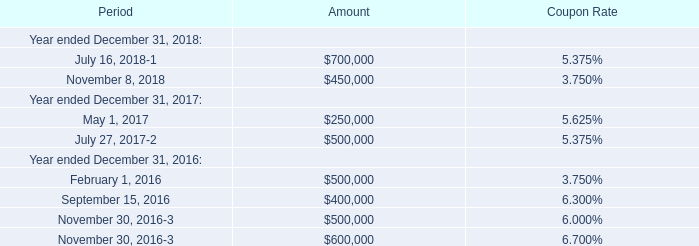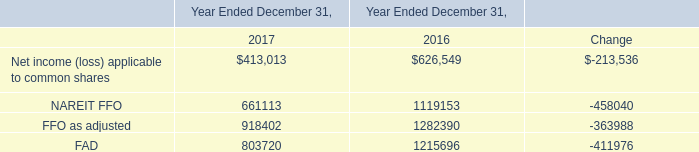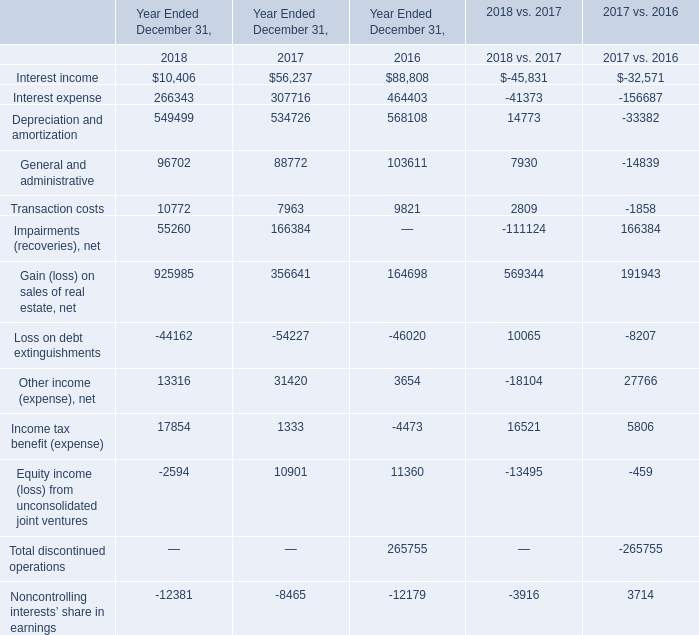What's the average of the Gain (loss) on sales of real estate, net in the years where NAREIT FFO is positive? 
Computations: ((356641 + 164698) / 2)
Answer: 260669.5. 